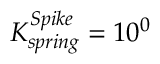<formula> <loc_0><loc_0><loc_500><loc_500>K _ { s p r i n g } ^ { S p i k e } = 1 0 ^ { 0 }</formula> 